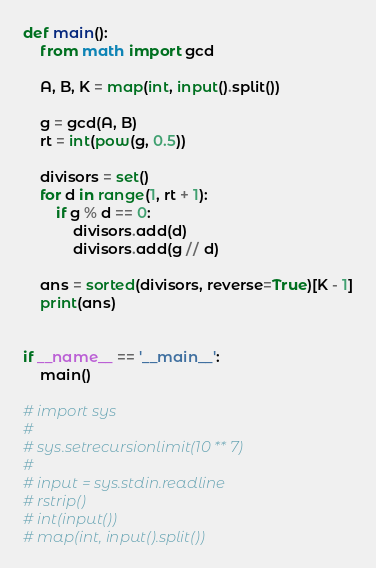Convert code to text. <code><loc_0><loc_0><loc_500><loc_500><_Python_>def main():
    from math import gcd

    A, B, K = map(int, input().split())

    g = gcd(A, B)
    rt = int(pow(g, 0.5))

    divisors = set()
    for d in range(1, rt + 1):
        if g % d == 0:
            divisors.add(d)
            divisors.add(g // d)

    ans = sorted(divisors, reverse=True)[K - 1]
    print(ans)


if __name__ == '__main__':
    main()

# import sys
#
# sys.setrecursionlimit(10 ** 7)
#
# input = sys.stdin.readline
# rstrip()
# int(input())
# map(int, input().split())
</code> 